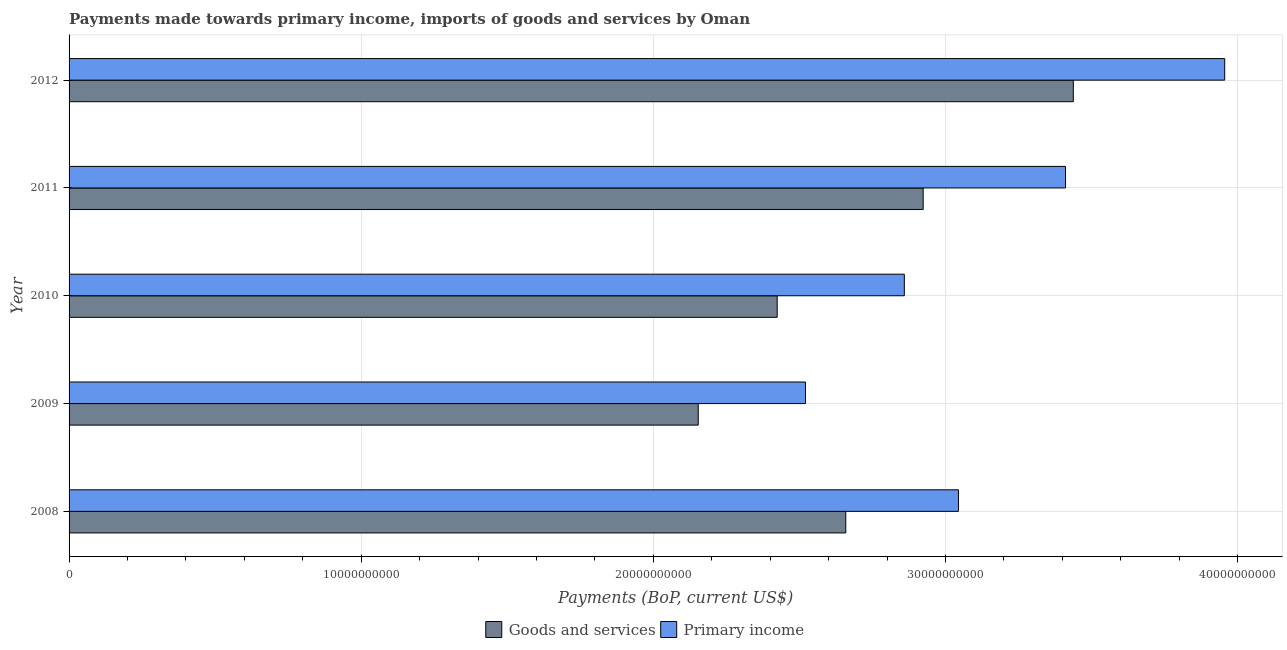How many groups of bars are there?
Ensure brevity in your answer.  5. How many bars are there on the 5th tick from the top?
Your answer should be compact. 2. What is the label of the 1st group of bars from the top?
Provide a short and direct response. 2012. What is the payments made towards goods and services in 2009?
Make the answer very short. 2.15e+1. Across all years, what is the maximum payments made towards primary income?
Keep it short and to the point. 3.96e+1. Across all years, what is the minimum payments made towards goods and services?
Provide a short and direct response. 2.15e+1. What is the total payments made towards primary income in the graph?
Make the answer very short. 1.58e+11. What is the difference between the payments made towards primary income in 2009 and that in 2012?
Provide a short and direct response. -1.43e+1. What is the difference between the payments made towards goods and services in 2010 and the payments made towards primary income in 2012?
Ensure brevity in your answer.  -1.53e+1. What is the average payments made towards goods and services per year?
Your answer should be very brief. 2.72e+1. In the year 2012, what is the difference between the payments made towards goods and services and payments made towards primary income?
Keep it short and to the point. -5.18e+09. What is the ratio of the payments made towards primary income in 2011 to that in 2012?
Give a very brief answer. 0.86. Is the payments made towards goods and services in 2008 less than that in 2012?
Give a very brief answer. Yes. Is the difference between the payments made towards goods and services in 2008 and 2012 greater than the difference between the payments made towards primary income in 2008 and 2012?
Offer a terse response. Yes. What is the difference between the highest and the second highest payments made towards primary income?
Offer a terse response. 5.45e+09. What is the difference between the highest and the lowest payments made towards primary income?
Ensure brevity in your answer.  1.43e+1. Is the sum of the payments made towards goods and services in 2010 and 2011 greater than the maximum payments made towards primary income across all years?
Offer a terse response. Yes. What does the 1st bar from the top in 2009 represents?
Your response must be concise. Primary income. What does the 2nd bar from the bottom in 2009 represents?
Offer a very short reply. Primary income. How many bars are there?
Offer a very short reply. 10. What is the difference between two consecutive major ticks on the X-axis?
Ensure brevity in your answer.  1.00e+1. Does the graph contain any zero values?
Your answer should be very brief. No. How many legend labels are there?
Offer a terse response. 2. How are the legend labels stacked?
Your answer should be very brief. Horizontal. What is the title of the graph?
Your answer should be very brief. Payments made towards primary income, imports of goods and services by Oman. What is the label or title of the X-axis?
Offer a terse response. Payments (BoP, current US$). What is the Payments (BoP, current US$) in Goods and services in 2008?
Ensure brevity in your answer.  2.66e+1. What is the Payments (BoP, current US$) of Primary income in 2008?
Offer a terse response. 3.04e+1. What is the Payments (BoP, current US$) in Goods and services in 2009?
Provide a short and direct response. 2.15e+1. What is the Payments (BoP, current US$) of Primary income in 2009?
Give a very brief answer. 2.52e+1. What is the Payments (BoP, current US$) of Goods and services in 2010?
Provide a short and direct response. 2.42e+1. What is the Payments (BoP, current US$) in Primary income in 2010?
Offer a very short reply. 2.86e+1. What is the Payments (BoP, current US$) in Goods and services in 2011?
Offer a very short reply. 2.92e+1. What is the Payments (BoP, current US$) in Primary income in 2011?
Give a very brief answer. 3.41e+1. What is the Payments (BoP, current US$) of Goods and services in 2012?
Provide a short and direct response. 3.44e+1. What is the Payments (BoP, current US$) in Primary income in 2012?
Your response must be concise. 3.96e+1. Across all years, what is the maximum Payments (BoP, current US$) of Goods and services?
Keep it short and to the point. 3.44e+1. Across all years, what is the maximum Payments (BoP, current US$) of Primary income?
Your response must be concise. 3.96e+1. Across all years, what is the minimum Payments (BoP, current US$) in Goods and services?
Keep it short and to the point. 2.15e+1. Across all years, what is the minimum Payments (BoP, current US$) of Primary income?
Offer a very short reply. 2.52e+1. What is the total Payments (BoP, current US$) of Goods and services in the graph?
Offer a very short reply. 1.36e+11. What is the total Payments (BoP, current US$) of Primary income in the graph?
Give a very brief answer. 1.58e+11. What is the difference between the Payments (BoP, current US$) of Goods and services in 2008 and that in 2009?
Your answer should be very brief. 5.05e+09. What is the difference between the Payments (BoP, current US$) of Primary income in 2008 and that in 2009?
Offer a very short reply. 5.24e+09. What is the difference between the Payments (BoP, current US$) of Goods and services in 2008 and that in 2010?
Make the answer very short. 2.35e+09. What is the difference between the Payments (BoP, current US$) of Primary income in 2008 and that in 2010?
Offer a terse response. 1.85e+09. What is the difference between the Payments (BoP, current US$) of Goods and services in 2008 and that in 2011?
Offer a very short reply. -2.65e+09. What is the difference between the Payments (BoP, current US$) of Primary income in 2008 and that in 2011?
Ensure brevity in your answer.  -3.66e+09. What is the difference between the Payments (BoP, current US$) in Goods and services in 2008 and that in 2012?
Your response must be concise. -7.79e+09. What is the difference between the Payments (BoP, current US$) of Primary income in 2008 and that in 2012?
Your response must be concise. -9.11e+09. What is the difference between the Payments (BoP, current US$) in Goods and services in 2009 and that in 2010?
Offer a terse response. -2.70e+09. What is the difference between the Payments (BoP, current US$) of Primary income in 2009 and that in 2010?
Keep it short and to the point. -3.38e+09. What is the difference between the Payments (BoP, current US$) in Goods and services in 2009 and that in 2011?
Give a very brief answer. -7.70e+09. What is the difference between the Payments (BoP, current US$) of Primary income in 2009 and that in 2011?
Make the answer very short. -8.90e+09. What is the difference between the Payments (BoP, current US$) in Goods and services in 2009 and that in 2012?
Your response must be concise. -1.28e+1. What is the difference between the Payments (BoP, current US$) in Primary income in 2009 and that in 2012?
Your response must be concise. -1.43e+1. What is the difference between the Payments (BoP, current US$) of Goods and services in 2010 and that in 2011?
Your response must be concise. -5.00e+09. What is the difference between the Payments (BoP, current US$) of Primary income in 2010 and that in 2011?
Provide a short and direct response. -5.52e+09. What is the difference between the Payments (BoP, current US$) of Goods and services in 2010 and that in 2012?
Give a very brief answer. -1.01e+1. What is the difference between the Payments (BoP, current US$) in Primary income in 2010 and that in 2012?
Provide a succinct answer. -1.10e+1. What is the difference between the Payments (BoP, current US$) in Goods and services in 2011 and that in 2012?
Ensure brevity in your answer.  -5.14e+09. What is the difference between the Payments (BoP, current US$) in Primary income in 2011 and that in 2012?
Provide a succinct answer. -5.45e+09. What is the difference between the Payments (BoP, current US$) in Goods and services in 2008 and the Payments (BoP, current US$) in Primary income in 2009?
Provide a succinct answer. 1.38e+09. What is the difference between the Payments (BoP, current US$) of Goods and services in 2008 and the Payments (BoP, current US$) of Primary income in 2010?
Make the answer very short. -2.00e+09. What is the difference between the Payments (BoP, current US$) of Goods and services in 2008 and the Payments (BoP, current US$) of Primary income in 2011?
Keep it short and to the point. -7.52e+09. What is the difference between the Payments (BoP, current US$) of Goods and services in 2008 and the Payments (BoP, current US$) of Primary income in 2012?
Provide a short and direct response. -1.30e+1. What is the difference between the Payments (BoP, current US$) of Goods and services in 2009 and the Payments (BoP, current US$) of Primary income in 2010?
Provide a short and direct response. -7.05e+09. What is the difference between the Payments (BoP, current US$) in Goods and services in 2009 and the Payments (BoP, current US$) in Primary income in 2011?
Provide a succinct answer. -1.26e+1. What is the difference between the Payments (BoP, current US$) in Goods and services in 2009 and the Payments (BoP, current US$) in Primary income in 2012?
Your response must be concise. -1.80e+1. What is the difference between the Payments (BoP, current US$) in Goods and services in 2010 and the Payments (BoP, current US$) in Primary income in 2011?
Offer a very short reply. -9.87e+09. What is the difference between the Payments (BoP, current US$) of Goods and services in 2010 and the Payments (BoP, current US$) of Primary income in 2012?
Make the answer very short. -1.53e+1. What is the difference between the Payments (BoP, current US$) in Goods and services in 2011 and the Payments (BoP, current US$) in Primary income in 2012?
Give a very brief answer. -1.03e+1. What is the average Payments (BoP, current US$) in Goods and services per year?
Offer a very short reply. 2.72e+1. What is the average Payments (BoP, current US$) of Primary income per year?
Your answer should be compact. 3.16e+1. In the year 2008, what is the difference between the Payments (BoP, current US$) in Goods and services and Payments (BoP, current US$) in Primary income?
Make the answer very short. -3.86e+09. In the year 2009, what is the difference between the Payments (BoP, current US$) in Goods and services and Payments (BoP, current US$) in Primary income?
Your answer should be compact. -3.67e+09. In the year 2010, what is the difference between the Payments (BoP, current US$) of Goods and services and Payments (BoP, current US$) of Primary income?
Ensure brevity in your answer.  -4.35e+09. In the year 2011, what is the difference between the Payments (BoP, current US$) of Goods and services and Payments (BoP, current US$) of Primary income?
Provide a succinct answer. -4.87e+09. In the year 2012, what is the difference between the Payments (BoP, current US$) of Goods and services and Payments (BoP, current US$) of Primary income?
Provide a short and direct response. -5.18e+09. What is the ratio of the Payments (BoP, current US$) in Goods and services in 2008 to that in 2009?
Make the answer very short. 1.23. What is the ratio of the Payments (BoP, current US$) in Primary income in 2008 to that in 2009?
Offer a very short reply. 1.21. What is the ratio of the Payments (BoP, current US$) of Goods and services in 2008 to that in 2010?
Your answer should be very brief. 1.1. What is the ratio of the Payments (BoP, current US$) in Primary income in 2008 to that in 2010?
Make the answer very short. 1.06. What is the ratio of the Payments (BoP, current US$) of Goods and services in 2008 to that in 2011?
Give a very brief answer. 0.91. What is the ratio of the Payments (BoP, current US$) in Primary income in 2008 to that in 2011?
Keep it short and to the point. 0.89. What is the ratio of the Payments (BoP, current US$) of Goods and services in 2008 to that in 2012?
Your response must be concise. 0.77. What is the ratio of the Payments (BoP, current US$) in Primary income in 2008 to that in 2012?
Provide a succinct answer. 0.77. What is the ratio of the Payments (BoP, current US$) of Goods and services in 2009 to that in 2010?
Give a very brief answer. 0.89. What is the ratio of the Payments (BoP, current US$) in Primary income in 2009 to that in 2010?
Ensure brevity in your answer.  0.88. What is the ratio of the Payments (BoP, current US$) in Goods and services in 2009 to that in 2011?
Your answer should be very brief. 0.74. What is the ratio of the Payments (BoP, current US$) of Primary income in 2009 to that in 2011?
Your answer should be very brief. 0.74. What is the ratio of the Payments (BoP, current US$) in Goods and services in 2009 to that in 2012?
Your response must be concise. 0.63. What is the ratio of the Payments (BoP, current US$) in Primary income in 2009 to that in 2012?
Offer a very short reply. 0.64. What is the ratio of the Payments (BoP, current US$) in Goods and services in 2010 to that in 2011?
Your answer should be compact. 0.83. What is the ratio of the Payments (BoP, current US$) in Primary income in 2010 to that in 2011?
Provide a short and direct response. 0.84. What is the ratio of the Payments (BoP, current US$) of Goods and services in 2010 to that in 2012?
Provide a succinct answer. 0.71. What is the ratio of the Payments (BoP, current US$) of Primary income in 2010 to that in 2012?
Your answer should be very brief. 0.72. What is the ratio of the Payments (BoP, current US$) in Goods and services in 2011 to that in 2012?
Offer a terse response. 0.85. What is the ratio of the Payments (BoP, current US$) of Primary income in 2011 to that in 2012?
Offer a very short reply. 0.86. What is the difference between the highest and the second highest Payments (BoP, current US$) in Goods and services?
Your answer should be compact. 5.14e+09. What is the difference between the highest and the second highest Payments (BoP, current US$) of Primary income?
Your answer should be compact. 5.45e+09. What is the difference between the highest and the lowest Payments (BoP, current US$) in Goods and services?
Your answer should be very brief. 1.28e+1. What is the difference between the highest and the lowest Payments (BoP, current US$) in Primary income?
Make the answer very short. 1.43e+1. 